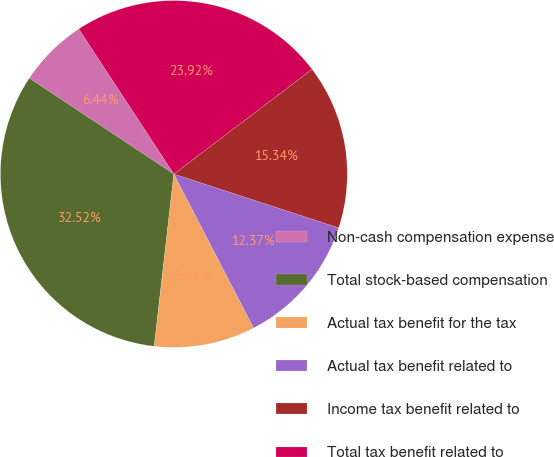Convert chart to OTSL. <chart><loc_0><loc_0><loc_500><loc_500><pie_chart><fcel>Non-cash compensation expense<fcel>Total stock-based compensation<fcel>Actual tax benefit for the tax<fcel>Actual tax benefit related to<fcel>Income tax benefit related to<fcel>Total tax benefit related to<nl><fcel>6.44%<fcel>32.52%<fcel>9.41%<fcel>12.37%<fcel>15.34%<fcel>23.92%<nl></chart> 